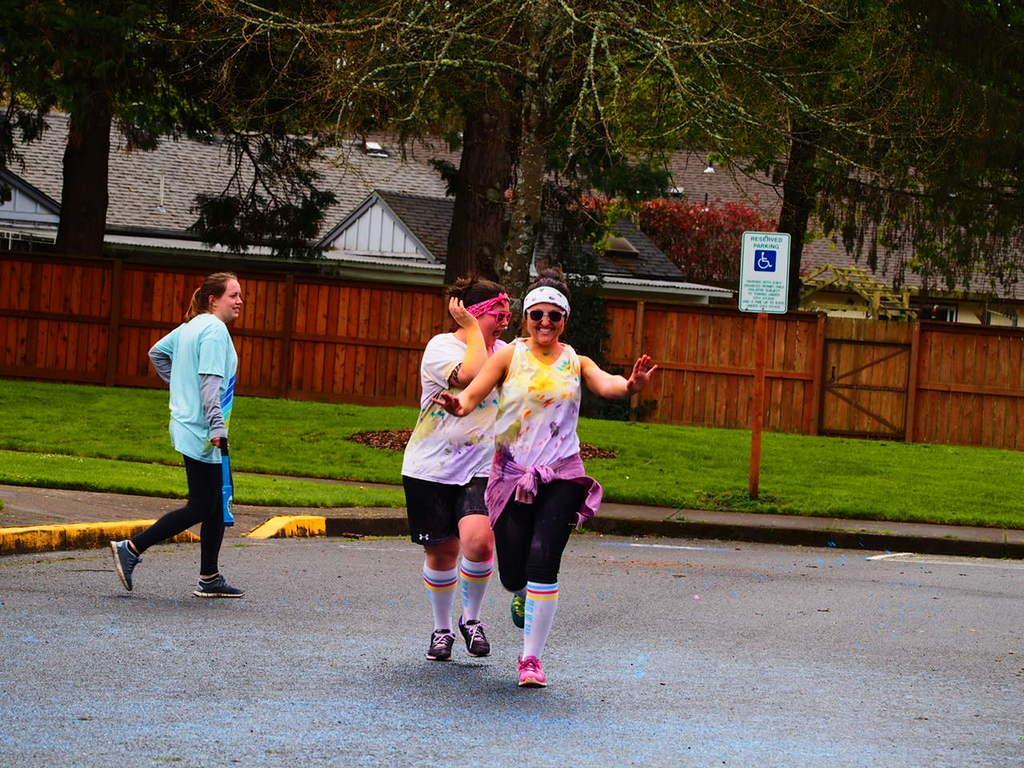How would you summarize this image in a sentence or two? In this picture I can see 3 women on the road and in the middle of this picture, I can see the grass and the wooden fencing. I can also see a pole on which there is a board and I see something is written on it. In the background I can see the trees and few buildings. 